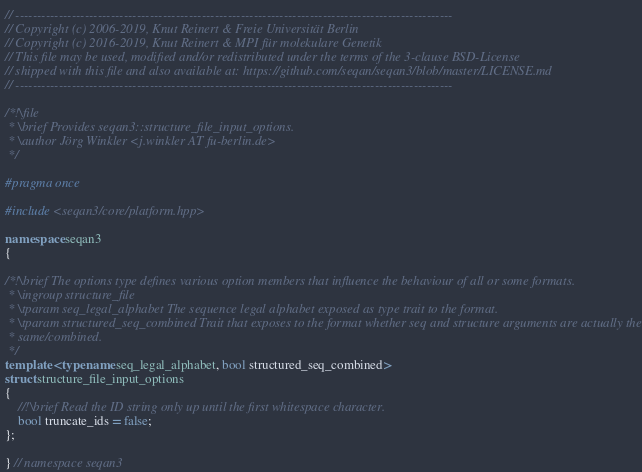<code> <loc_0><loc_0><loc_500><loc_500><_C++_>// -----------------------------------------------------------------------------------------------------
// Copyright (c) 2006-2019, Knut Reinert & Freie Universität Berlin
// Copyright (c) 2016-2019, Knut Reinert & MPI für molekulare Genetik
// This file may be used, modified and/or redistributed under the terms of the 3-clause BSD-License
// shipped with this file and also available at: https://github.com/seqan/seqan3/blob/master/LICENSE.md
// -----------------------------------------------------------------------------------------------------

/*!\file
 * \brief Provides seqan3::structure_file_input_options.
 * \author Jörg Winkler <j.winkler AT fu-berlin.de>
 */

#pragma once

#include <seqan3/core/platform.hpp>

namespace seqan3
{

/*!\brief The options type defines various option members that influence the behaviour of all or some formats.
 * \ingroup structure_file
 * \tparam seq_legal_alphabet The sequence legal alphabet exposed as type trait to the format.
 * \tparam structured_seq_combined Trait that exposes to the format whether seq and structure arguments are actually the
 * same/combined.
 */
template <typename seq_legal_alphabet, bool structured_seq_combined>
struct structure_file_input_options
{
    //!\brief Read the ID string only up until the first whitespace character.
    bool truncate_ids = false;
};

} // namespace seqan3
</code> 